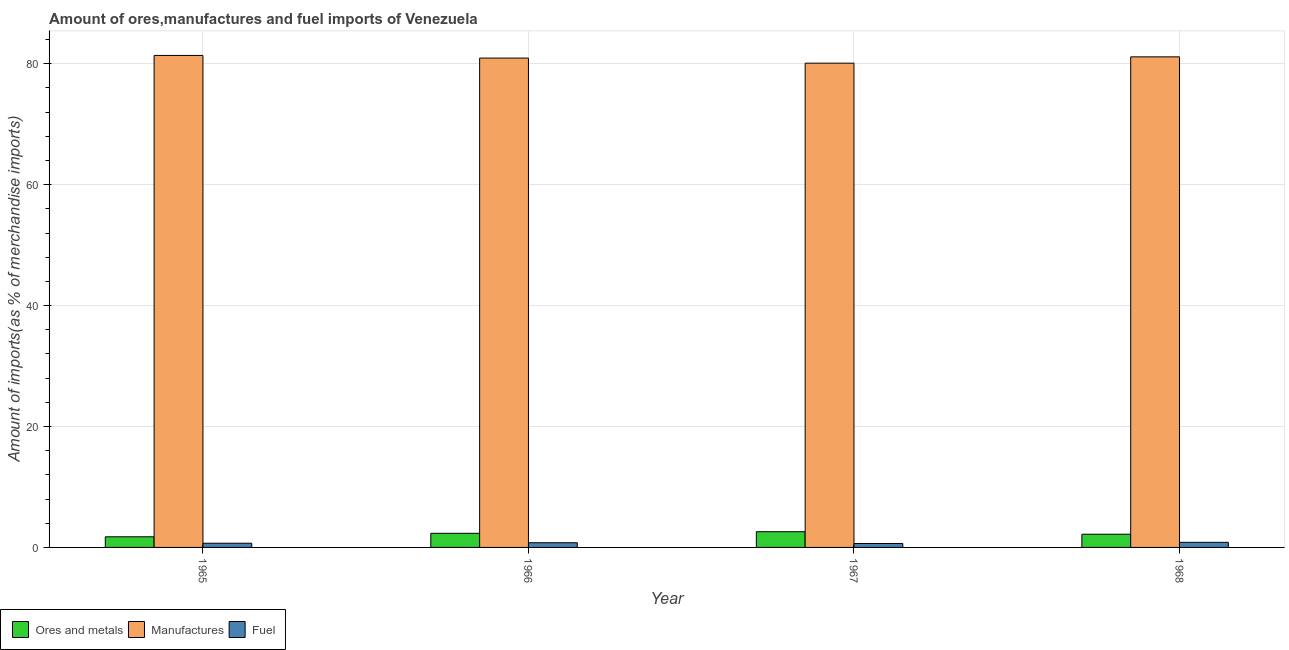How many different coloured bars are there?
Offer a terse response. 3. How many groups of bars are there?
Your response must be concise. 4. Are the number of bars per tick equal to the number of legend labels?
Ensure brevity in your answer.  Yes. How many bars are there on the 1st tick from the left?
Provide a succinct answer. 3. What is the label of the 2nd group of bars from the left?
Your answer should be compact. 1966. In how many cases, is the number of bars for a given year not equal to the number of legend labels?
Provide a succinct answer. 0. What is the percentage of ores and metals imports in 1965?
Your answer should be very brief. 1.76. Across all years, what is the maximum percentage of manufactures imports?
Give a very brief answer. 81.39. Across all years, what is the minimum percentage of manufactures imports?
Offer a very short reply. 80.1. In which year was the percentage of fuel imports maximum?
Your answer should be compact. 1968. In which year was the percentage of manufactures imports minimum?
Your response must be concise. 1967. What is the total percentage of manufactures imports in the graph?
Give a very brief answer. 323.59. What is the difference between the percentage of manufactures imports in 1965 and that in 1967?
Your response must be concise. 1.28. What is the difference between the percentage of manufactures imports in 1966 and the percentage of ores and metals imports in 1968?
Keep it short and to the point. -0.2. What is the average percentage of ores and metals imports per year?
Your answer should be very brief. 2.22. In the year 1968, what is the difference between the percentage of fuel imports and percentage of ores and metals imports?
Provide a short and direct response. 0. In how many years, is the percentage of ores and metals imports greater than 56 %?
Provide a short and direct response. 0. What is the ratio of the percentage of fuel imports in 1966 to that in 1967?
Provide a short and direct response. 1.19. What is the difference between the highest and the second highest percentage of manufactures imports?
Provide a short and direct response. 0.24. What is the difference between the highest and the lowest percentage of ores and metals imports?
Your answer should be compact. 0.84. In how many years, is the percentage of manufactures imports greater than the average percentage of manufactures imports taken over all years?
Provide a succinct answer. 3. Is the sum of the percentage of ores and metals imports in 1966 and 1968 greater than the maximum percentage of fuel imports across all years?
Provide a short and direct response. Yes. What does the 3rd bar from the left in 1967 represents?
Offer a terse response. Fuel. What does the 2nd bar from the right in 1966 represents?
Make the answer very short. Manufactures. Is it the case that in every year, the sum of the percentage of ores and metals imports and percentage of manufactures imports is greater than the percentage of fuel imports?
Give a very brief answer. Yes. How many bars are there?
Provide a succinct answer. 12. How many years are there in the graph?
Ensure brevity in your answer.  4. What is the difference between two consecutive major ticks on the Y-axis?
Make the answer very short. 20. Are the values on the major ticks of Y-axis written in scientific E-notation?
Your answer should be very brief. No. Does the graph contain any zero values?
Offer a very short reply. No. Does the graph contain grids?
Keep it short and to the point. Yes. How are the legend labels stacked?
Provide a short and direct response. Horizontal. What is the title of the graph?
Ensure brevity in your answer.  Amount of ores,manufactures and fuel imports of Venezuela. Does "Financial account" appear as one of the legend labels in the graph?
Provide a short and direct response. No. What is the label or title of the X-axis?
Offer a very short reply. Year. What is the label or title of the Y-axis?
Your answer should be very brief. Amount of imports(as % of merchandise imports). What is the Amount of imports(as % of merchandise imports) in Ores and metals in 1965?
Provide a succinct answer. 1.76. What is the Amount of imports(as % of merchandise imports) in Manufactures in 1965?
Give a very brief answer. 81.39. What is the Amount of imports(as % of merchandise imports) in Fuel in 1965?
Offer a very short reply. 0.69. What is the Amount of imports(as % of merchandise imports) in Ores and metals in 1966?
Offer a terse response. 2.34. What is the Amount of imports(as % of merchandise imports) in Manufactures in 1966?
Make the answer very short. 80.95. What is the Amount of imports(as % of merchandise imports) of Fuel in 1966?
Make the answer very short. 0.78. What is the Amount of imports(as % of merchandise imports) of Ores and metals in 1967?
Offer a terse response. 2.6. What is the Amount of imports(as % of merchandise imports) in Manufactures in 1967?
Your response must be concise. 80.1. What is the Amount of imports(as % of merchandise imports) of Fuel in 1967?
Your answer should be very brief. 0.65. What is the Amount of imports(as % of merchandise imports) of Ores and metals in 1968?
Provide a short and direct response. 2.19. What is the Amount of imports(as % of merchandise imports) of Manufactures in 1968?
Provide a succinct answer. 81.15. What is the Amount of imports(as % of merchandise imports) in Fuel in 1968?
Keep it short and to the point. 0.84. Across all years, what is the maximum Amount of imports(as % of merchandise imports) in Ores and metals?
Offer a very short reply. 2.6. Across all years, what is the maximum Amount of imports(as % of merchandise imports) of Manufactures?
Give a very brief answer. 81.39. Across all years, what is the maximum Amount of imports(as % of merchandise imports) in Fuel?
Offer a terse response. 0.84. Across all years, what is the minimum Amount of imports(as % of merchandise imports) in Ores and metals?
Give a very brief answer. 1.76. Across all years, what is the minimum Amount of imports(as % of merchandise imports) of Manufactures?
Keep it short and to the point. 80.1. Across all years, what is the minimum Amount of imports(as % of merchandise imports) in Fuel?
Offer a very short reply. 0.65. What is the total Amount of imports(as % of merchandise imports) of Ores and metals in the graph?
Offer a terse response. 8.88. What is the total Amount of imports(as % of merchandise imports) in Manufactures in the graph?
Offer a terse response. 323.59. What is the total Amount of imports(as % of merchandise imports) in Fuel in the graph?
Keep it short and to the point. 2.96. What is the difference between the Amount of imports(as % of merchandise imports) in Ores and metals in 1965 and that in 1966?
Your answer should be very brief. -0.58. What is the difference between the Amount of imports(as % of merchandise imports) in Manufactures in 1965 and that in 1966?
Your response must be concise. 0.44. What is the difference between the Amount of imports(as % of merchandise imports) of Fuel in 1965 and that in 1966?
Offer a terse response. -0.08. What is the difference between the Amount of imports(as % of merchandise imports) in Ores and metals in 1965 and that in 1967?
Provide a succinct answer. -0.84. What is the difference between the Amount of imports(as % of merchandise imports) in Manufactures in 1965 and that in 1967?
Ensure brevity in your answer.  1.28. What is the difference between the Amount of imports(as % of merchandise imports) in Fuel in 1965 and that in 1967?
Make the answer very short. 0.04. What is the difference between the Amount of imports(as % of merchandise imports) in Ores and metals in 1965 and that in 1968?
Give a very brief answer. -0.43. What is the difference between the Amount of imports(as % of merchandise imports) in Manufactures in 1965 and that in 1968?
Keep it short and to the point. 0.24. What is the difference between the Amount of imports(as % of merchandise imports) in Fuel in 1965 and that in 1968?
Offer a terse response. -0.15. What is the difference between the Amount of imports(as % of merchandise imports) of Ores and metals in 1966 and that in 1967?
Provide a short and direct response. -0.26. What is the difference between the Amount of imports(as % of merchandise imports) of Manufactures in 1966 and that in 1967?
Make the answer very short. 0.84. What is the difference between the Amount of imports(as % of merchandise imports) in Fuel in 1966 and that in 1967?
Give a very brief answer. 0.13. What is the difference between the Amount of imports(as % of merchandise imports) in Ores and metals in 1966 and that in 1968?
Provide a short and direct response. 0.15. What is the difference between the Amount of imports(as % of merchandise imports) in Manufactures in 1966 and that in 1968?
Offer a terse response. -0.2. What is the difference between the Amount of imports(as % of merchandise imports) in Fuel in 1966 and that in 1968?
Ensure brevity in your answer.  -0.07. What is the difference between the Amount of imports(as % of merchandise imports) in Ores and metals in 1967 and that in 1968?
Provide a short and direct response. 0.41. What is the difference between the Amount of imports(as % of merchandise imports) in Manufactures in 1967 and that in 1968?
Provide a succinct answer. -1.04. What is the difference between the Amount of imports(as % of merchandise imports) of Fuel in 1967 and that in 1968?
Ensure brevity in your answer.  -0.19. What is the difference between the Amount of imports(as % of merchandise imports) of Ores and metals in 1965 and the Amount of imports(as % of merchandise imports) of Manufactures in 1966?
Ensure brevity in your answer.  -79.19. What is the difference between the Amount of imports(as % of merchandise imports) of Ores and metals in 1965 and the Amount of imports(as % of merchandise imports) of Fuel in 1966?
Give a very brief answer. 0.98. What is the difference between the Amount of imports(as % of merchandise imports) in Manufactures in 1965 and the Amount of imports(as % of merchandise imports) in Fuel in 1966?
Give a very brief answer. 80.61. What is the difference between the Amount of imports(as % of merchandise imports) in Ores and metals in 1965 and the Amount of imports(as % of merchandise imports) in Manufactures in 1967?
Make the answer very short. -78.35. What is the difference between the Amount of imports(as % of merchandise imports) of Ores and metals in 1965 and the Amount of imports(as % of merchandise imports) of Fuel in 1967?
Your answer should be compact. 1.11. What is the difference between the Amount of imports(as % of merchandise imports) of Manufactures in 1965 and the Amount of imports(as % of merchandise imports) of Fuel in 1967?
Offer a very short reply. 80.74. What is the difference between the Amount of imports(as % of merchandise imports) of Ores and metals in 1965 and the Amount of imports(as % of merchandise imports) of Manufactures in 1968?
Provide a short and direct response. -79.39. What is the difference between the Amount of imports(as % of merchandise imports) in Ores and metals in 1965 and the Amount of imports(as % of merchandise imports) in Fuel in 1968?
Give a very brief answer. 0.92. What is the difference between the Amount of imports(as % of merchandise imports) of Manufactures in 1965 and the Amount of imports(as % of merchandise imports) of Fuel in 1968?
Provide a succinct answer. 80.54. What is the difference between the Amount of imports(as % of merchandise imports) in Ores and metals in 1966 and the Amount of imports(as % of merchandise imports) in Manufactures in 1967?
Make the answer very short. -77.77. What is the difference between the Amount of imports(as % of merchandise imports) in Ores and metals in 1966 and the Amount of imports(as % of merchandise imports) in Fuel in 1967?
Your response must be concise. 1.69. What is the difference between the Amount of imports(as % of merchandise imports) of Manufactures in 1966 and the Amount of imports(as % of merchandise imports) of Fuel in 1967?
Keep it short and to the point. 80.3. What is the difference between the Amount of imports(as % of merchandise imports) of Ores and metals in 1966 and the Amount of imports(as % of merchandise imports) of Manufactures in 1968?
Your answer should be compact. -78.81. What is the difference between the Amount of imports(as % of merchandise imports) of Ores and metals in 1966 and the Amount of imports(as % of merchandise imports) of Fuel in 1968?
Provide a short and direct response. 1.49. What is the difference between the Amount of imports(as % of merchandise imports) of Manufactures in 1966 and the Amount of imports(as % of merchandise imports) of Fuel in 1968?
Offer a very short reply. 80.1. What is the difference between the Amount of imports(as % of merchandise imports) of Ores and metals in 1967 and the Amount of imports(as % of merchandise imports) of Manufactures in 1968?
Your answer should be compact. -78.55. What is the difference between the Amount of imports(as % of merchandise imports) of Ores and metals in 1967 and the Amount of imports(as % of merchandise imports) of Fuel in 1968?
Your answer should be very brief. 1.76. What is the difference between the Amount of imports(as % of merchandise imports) of Manufactures in 1967 and the Amount of imports(as % of merchandise imports) of Fuel in 1968?
Offer a very short reply. 79.26. What is the average Amount of imports(as % of merchandise imports) of Ores and metals per year?
Your answer should be compact. 2.22. What is the average Amount of imports(as % of merchandise imports) of Manufactures per year?
Your response must be concise. 80.9. What is the average Amount of imports(as % of merchandise imports) in Fuel per year?
Provide a short and direct response. 0.74. In the year 1965, what is the difference between the Amount of imports(as % of merchandise imports) in Ores and metals and Amount of imports(as % of merchandise imports) in Manufactures?
Give a very brief answer. -79.63. In the year 1965, what is the difference between the Amount of imports(as % of merchandise imports) in Ores and metals and Amount of imports(as % of merchandise imports) in Fuel?
Keep it short and to the point. 1.06. In the year 1965, what is the difference between the Amount of imports(as % of merchandise imports) in Manufactures and Amount of imports(as % of merchandise imports) in Fuel?
Provide a succinct answer. 80.69. In the year 1966, what is the difference between the Amount of imports(as % of merchandise imports) of Ores and metals and Amount of imports(as % of merchandise imports) of Manufactures?
Provide a short and direct response. -78.61. In the year 1966, what is the difference between the Amount of imports(as % of merchandise imports) of Ores and metals and Amount of imports(as % of merchandise imports) of Fuel?
Your answer should be compact. 1.56. In the year 1966, what is the difference between the Amount of imports(as % of merchandise imports) of Manufactures and Amount of imports(as % of merchandise imports) of Fuel?
Offer a very short reply. 80.17. In the year 1967, what is the difference between the Amount of imports(as % of merchandise imports) of Ores and metals and Amount of imports(as % of merchandise imports) of Manufactures?
Your answer should be compact. -77.5. In the year 1967, what is the difference between the Amount of imports(as % of merchandise imports) in Ores and metals and Amount of imports(as % of merchandise imports) in Fuel?
Offer a terse response. 1.95. In the year 1967, what is the difference between the Amount of imports(as % of merchandise imports) of Manufactures and Amount of imports(as % of merchandise imports) of Fuel?
Your response must be concise. 79.46. In the year 1968, what is the difference between the Amount of imports(as % of merchandise imports) of Ores and metals and Amount of imports(as % of merchandise imports) of Manufactures?
Offer a very short reply. -78.96. In the year 1968, what is the difference between the Amount of imports(as % of merchandise imports) in Ores and metals and Amount of imports(as % of merchandise imports) in Fuel?
Your answer should be very brief. 1.34. In the year 1968, what is the difference between the Amount of imports(as % of merchandise imports) of Manufactures and Amount of imports(as % of merchandise imports) of Fuel?
Your answer should be compact. 80.31. What is the ratio of the Amount of imports(as % of merchandise imports) in Ores and metals in 1965 to that in 1966?
Provide a short and direct response. 0.75. What is the ratio of the Amount of imports(as % of merchandise imports) in Manufactures in 1965 to that in 1966?
Your answer should be compact. 1.01. What is the ratio of the Amount of imports(as % of merchandise imports) of Fuel in 1965 to that in 1966?
Your response must be concise. 0.89. What is the ratio of the Amount of imports(as % of merchandise imports) of Ores and metals in 1965 to that in 1967?
Offer a terse response. 0.68. What is the ratio of the Amount of imports(as % of merchandise imports) in Manufactures in 1965 to that in 1967?
Provide a short and direct response. 1.02. What is the ratio of the Amount of imports(as % of merchandise imports) in Fuel in 1965 to that in 1967?
Provide a short and direct response. 1.07. What is the ratio of the Amount of imports(as % of merchandise imports) of Ores and metals in 1965 to that in 1968?
Make the answer very short. 0.8. What is the ratio of the Amount of imports(as % of merchandise imports) in Fuel in 1965 to that in 1968?
Offer a terse response. 0.82. What is the ratio of the Amount of imports(as % of merchandise imports) of Ores and metals in 1966 to that in 1967?
Your answer should be compact. 0.9. What is the ratio of the Amount of imports(as % of merchandise imports) of Manufactures in 1966 to that in 1967?
Your answer should be very brief. 1.01. What is the ratio of the Amount of imports(as % of merchandise imports) in Fuel in 1966 to that in 1967?
Your answer should be compact. 1.19. What is the ratio of the Amount of imports(as % of merchandise imports) of Ores and metals in 1966 to that in 1968?
Your answer should be very brief. 1.07. What is the ratio of the Amount of imports(as % of merchandise imports) of Fuel in 1966 to that in 1968?
Keep it short and to the point. 0.92. What is the ratio of the Amount of imports(as % of merchandise imports) in Ores and metals in 1967 to that in 1968?
Ensure brevity in your answer.  1.19. What is the ratio of the Amount of imports(as % of merchandise imports) of Manufactures in 1967 to that in 1968?
Keep it short and to the point. 0.99. What is the ratio of the Amount of imports(as % of merchandise imports) in Fuel in 1967 to that in 1968?
Keep it short and to the point. 0.77. What is the difference between the highest and the second highest Amount of imports(as % of merchandise imports) of Ores and metals?
Ensure brevity in your answer.  0.26. What is the difference between the highest and the second highest Amount of imports(as % of merchandise imports) in Manufactures?
Offer a very short reply. 0.24. What is the difference between the highest and the second highest Amount of imports(as % of merchandise imports) in Fuel?
Provide a succinct answer. 0.07. What is the difference between the highest and the lowest Amount of imports(as % of merchandise imports) in Ores and metals?
Your answer should be very brief. 0.84. What is the difference between the highest and the lowest Amount of imports(as % of merchandise imports) of Manufactures?
Your response must be concise. 1.28. What is the difference between the highest and the lowest Amount of imports(as % of merchandise imports) in Fuel?
Keep it short and to the point. 0.19. 